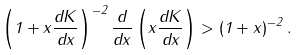<formula> <loc_0><loc_0><loc_500><loc_500>\left ( 1 + x \frac { d K } { d x } \right ) ^ { - 2 } \frac { d } { d x } \left ( x \frac { d K } { d x } \right ) > \left ( 1 + x \right ) ^ { - 2 } .</formula> 